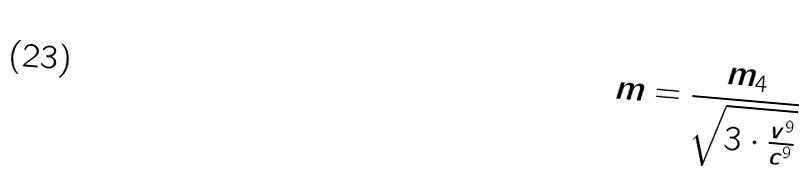<formula> <loc_0><loc_0><loc_500><loc_500>m = \frac { m _ { 4 } } { \sqrt { 3 \cdot \frac { v ^ { 9 } } { c ^ { 9 } } } }</formula> 